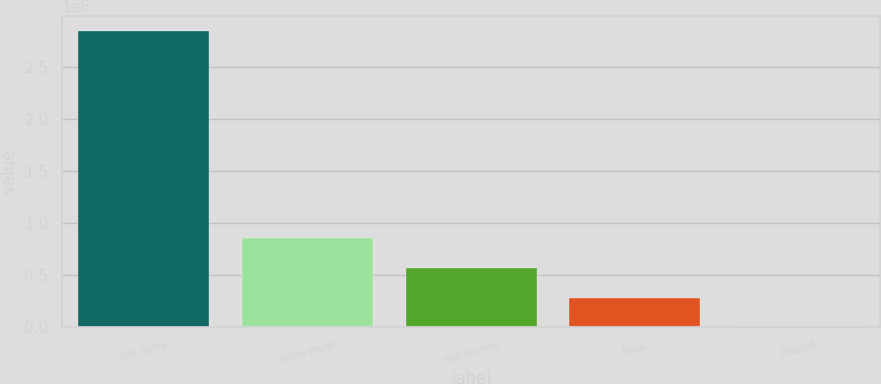Convert chart to OTSL. <chart><loc_0><loc_0><loc_500><loc_500><bar_chart><fcel>Net Sales<fcel>Gross Profit<fcel>Net Income<fcel>Basic<fcel>Diluted<nl><fcel>2.84719e+06<fcel>854156<fcel>569438<fcel>284719<fcel>0.78<nl></chart> 